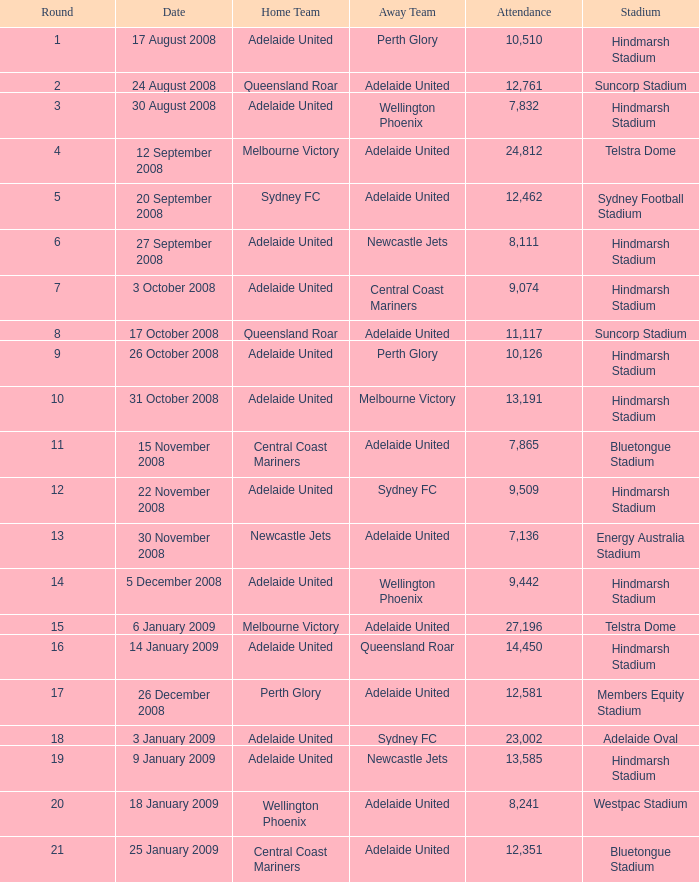When 11,117 spectators were present at the game on october 26, 2008, which round was it? 9.0. 